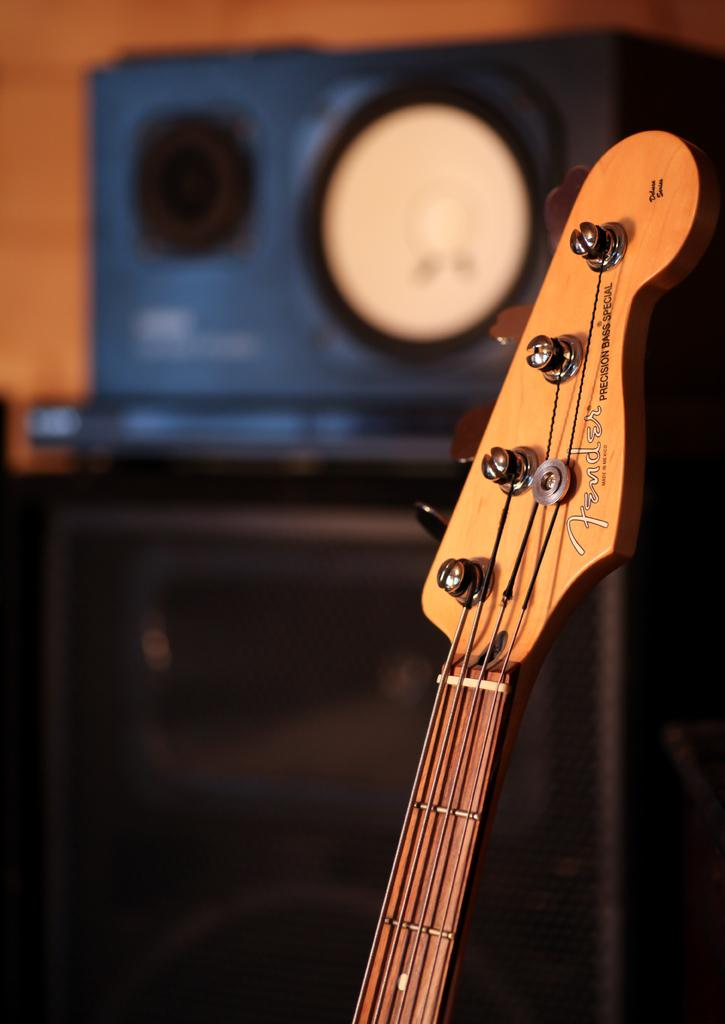What musical instrument is visible in the image? There is a guitar in the image. What might be used to amplify sound in the image? There are speakers in the image. What type of structure is present in the image? There is a wall in the image. Is there any text or writing on the guitar? Yes, there is text on the guitar. What type of pies are being served at the battle in the image? There is no battle or pies present in the image; it features a guitar and speakers. 